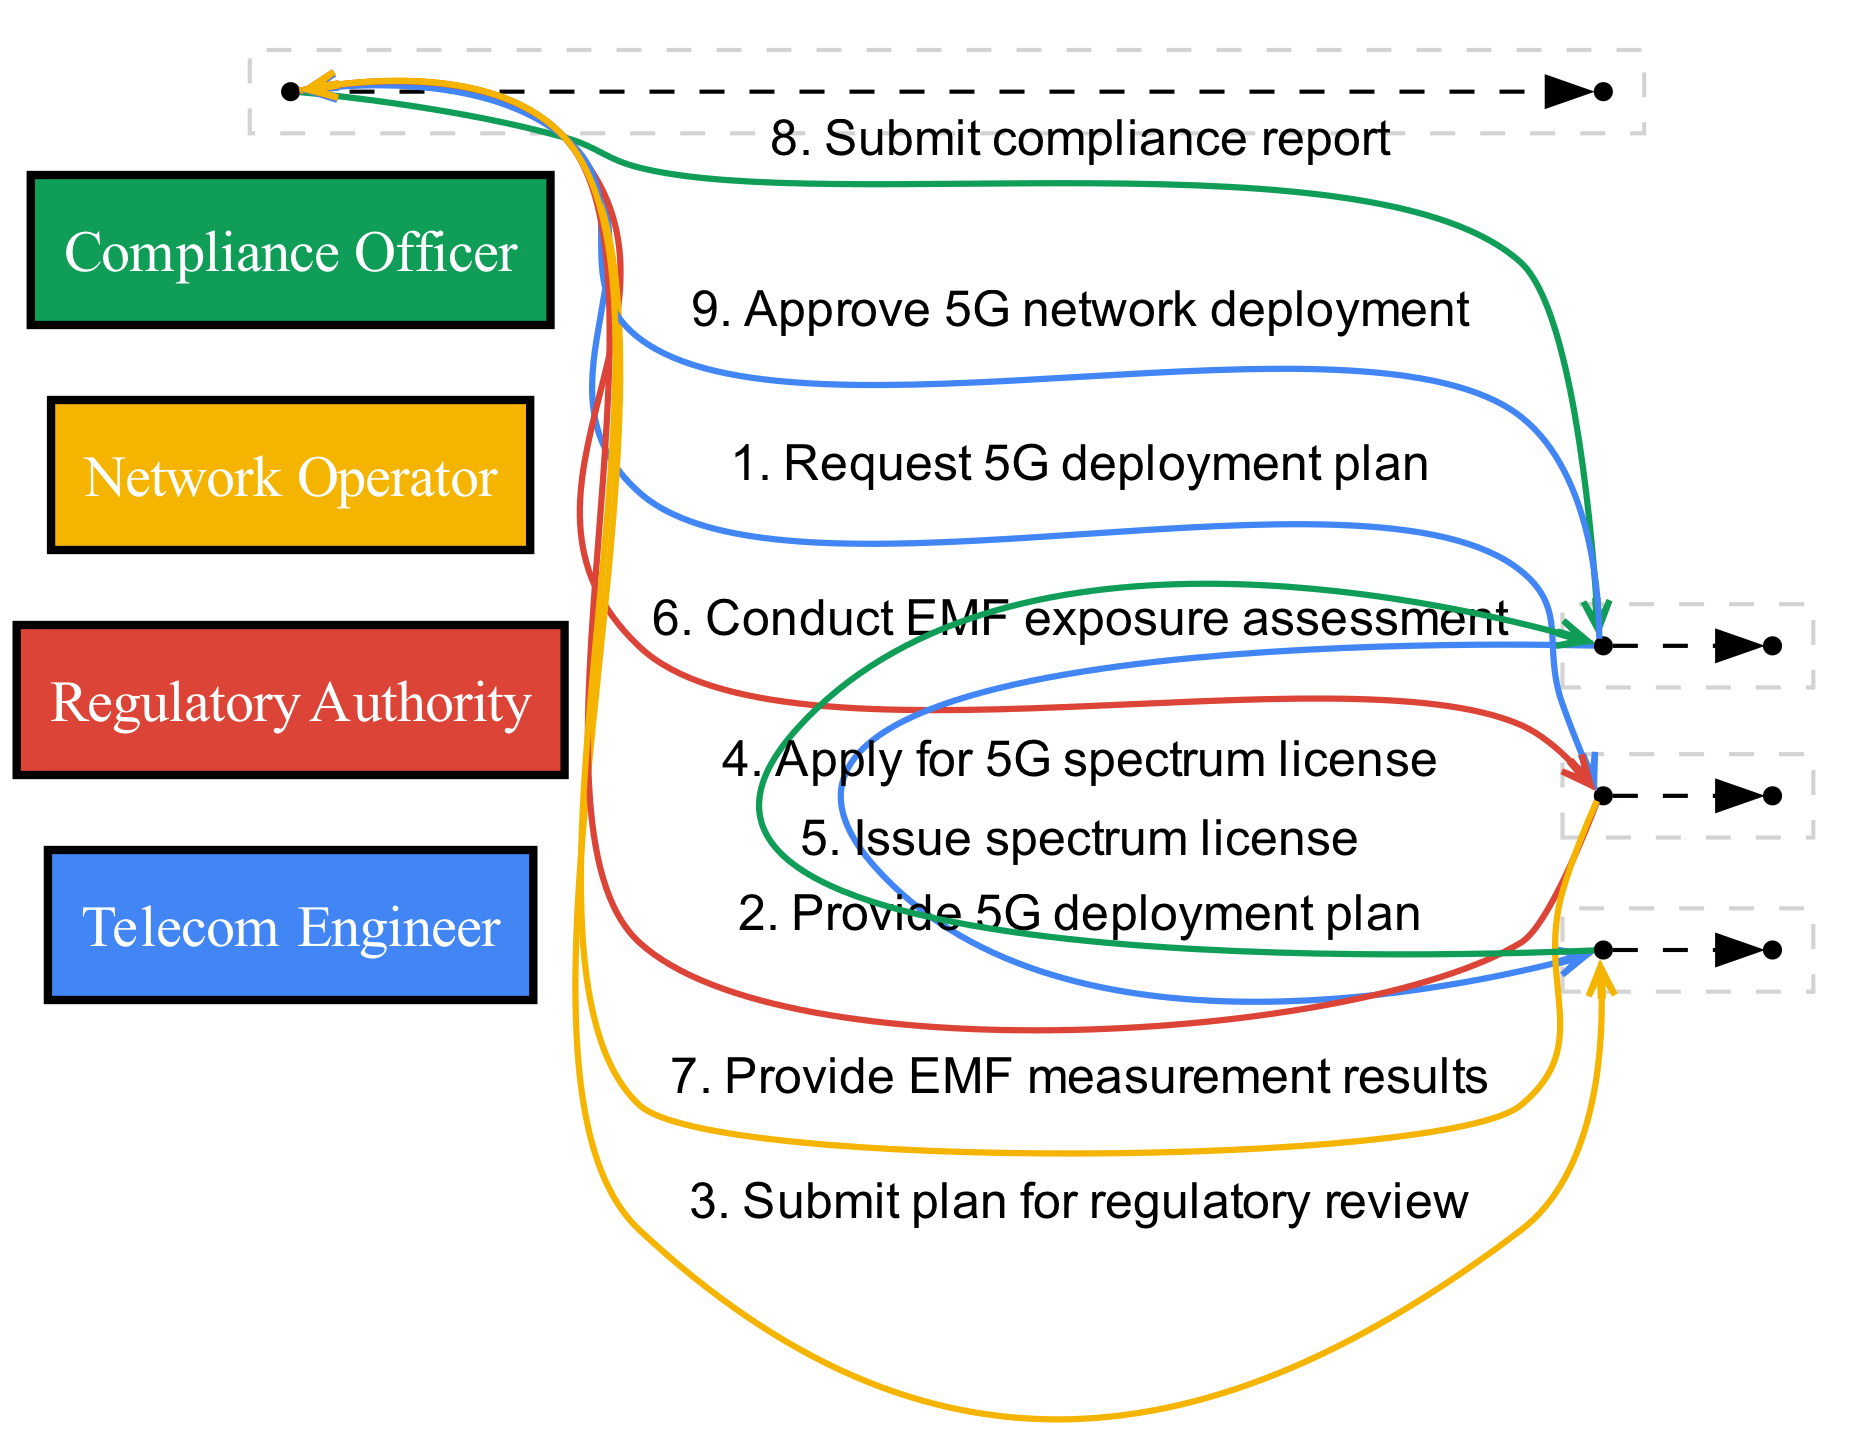What is the first step in the sequence? The first step shows the Telecom Engineer requesting the 5G deployment plan from the Network Operator.
Answer: Request 5G deployment plan How many actors are involved in this sequence diagram? By counting the unique entities, we find there are four actors: Telecom Engineer, Regulatory Authority, Network Operator, and Compliance Officer.
Answer: Four What does the Compliance Officer do after receiving the 5G deployment plan? The Compliance Officer submits the plan for regulatory review after receiving it from the Telecom Engineer.
Answer: Submit plan for regulatory review Who issues the spectrum license? The diagram shows that the Regulatory Authority is responsible for issuing the spectrum license to the Compliance Officer after application.
Answer: Regulatory Authority What is the final step in the sequence? The final step indicates the Regulatory Authority approves the 5G network deployment, concluding the sequence of actions.
Answer: Approve 5G network deployment Which actor conducts the EMF exposure assessment? According to the diagram, the Telecom Engineer is responsible for conducting the EMF exposure assessment.
Answer: Telecom Engineer How many messages are exchanged before the Compliance Officer submits a report? There are five messages exchanged before the Telecom Engineer submits the compliance report to the Regulatory Authority.
Answer: Five What action does the Network Operator take after the EMF assessment? After conducting the EMF exposure assessment, the Network Operator provides the EMF measurement results to the Telecom Engineer.
Answer: Provide EMF measurement results What is the relationship between the Telecom Engineer and the Network Operator in the diagram? The relationship is that the Telecom Engineer requests and receives information from the Network Operator, illustrating a collaborative workflow.
Answer: Collaborative workflow 